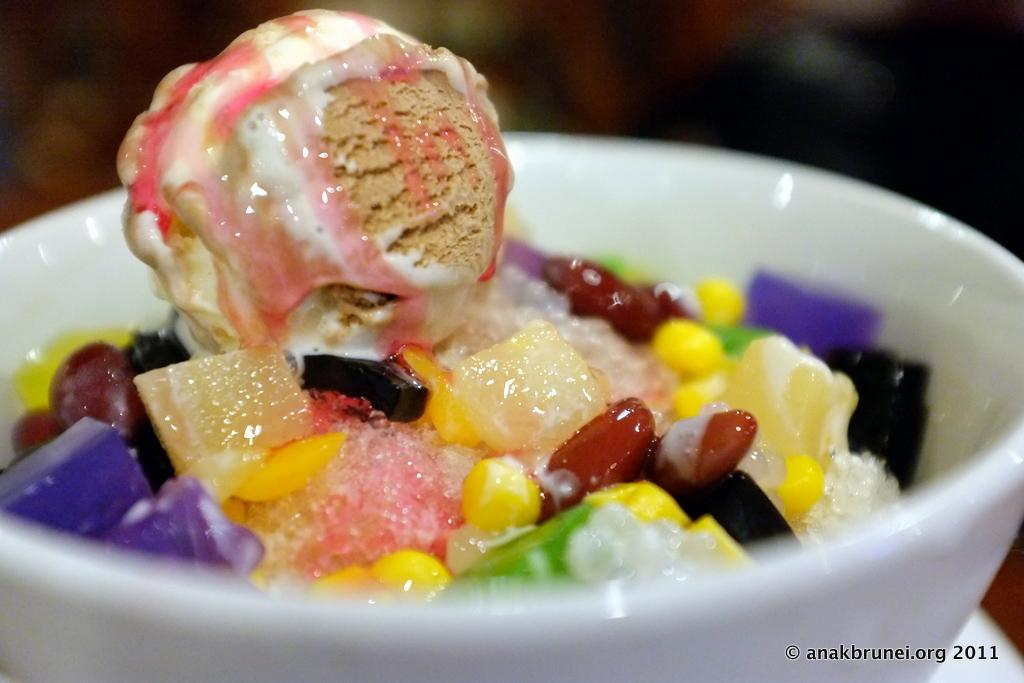What is in the bowl that is visible in the image? There is food in a bowl in the image. What can be found at the bottom of the image? There is text at the bottom of the image. How would you describe the background at the top of the image? The background at the top of the image is blurred. What type of army is depicted in the image? There is no army present in the image. What material is the brass used for in the image? There is no brass present in the image. 